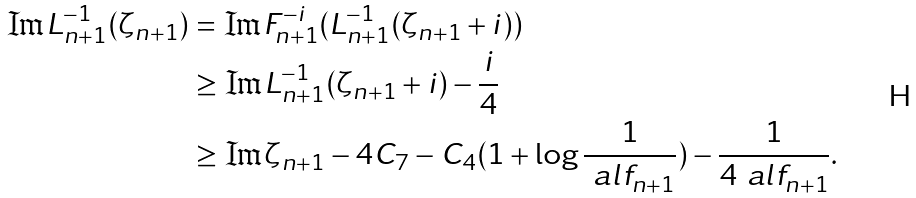<formula> <loc_0><loc_0><loc_500><loc_500>\Im L _ { n + 1 } ^ { - 1 } ( \zeta _ { n + 1 } ) & = \Im F _ { n + 1 } ^ { - i } ( L _ { n + 1 } ^ { - 1 } ( \zeta _ { n + 1 } + i ) ) \\ & \geq \Im L _ { n + 1 } ^ { - 1 } ( \zeta _ { n + 1 } + i ) - \frac { i } { 4 } \\ & \geq \Im \zeta _ { n + 1 } - 4 C _ { 7 } - C _ { 4 } ( 1 + \log \frac { 1 } { \ a l f _ { n + 1 } } ) - \frac { 1 } { 4 \ a l f _ { n + 1 } } .</formula> 